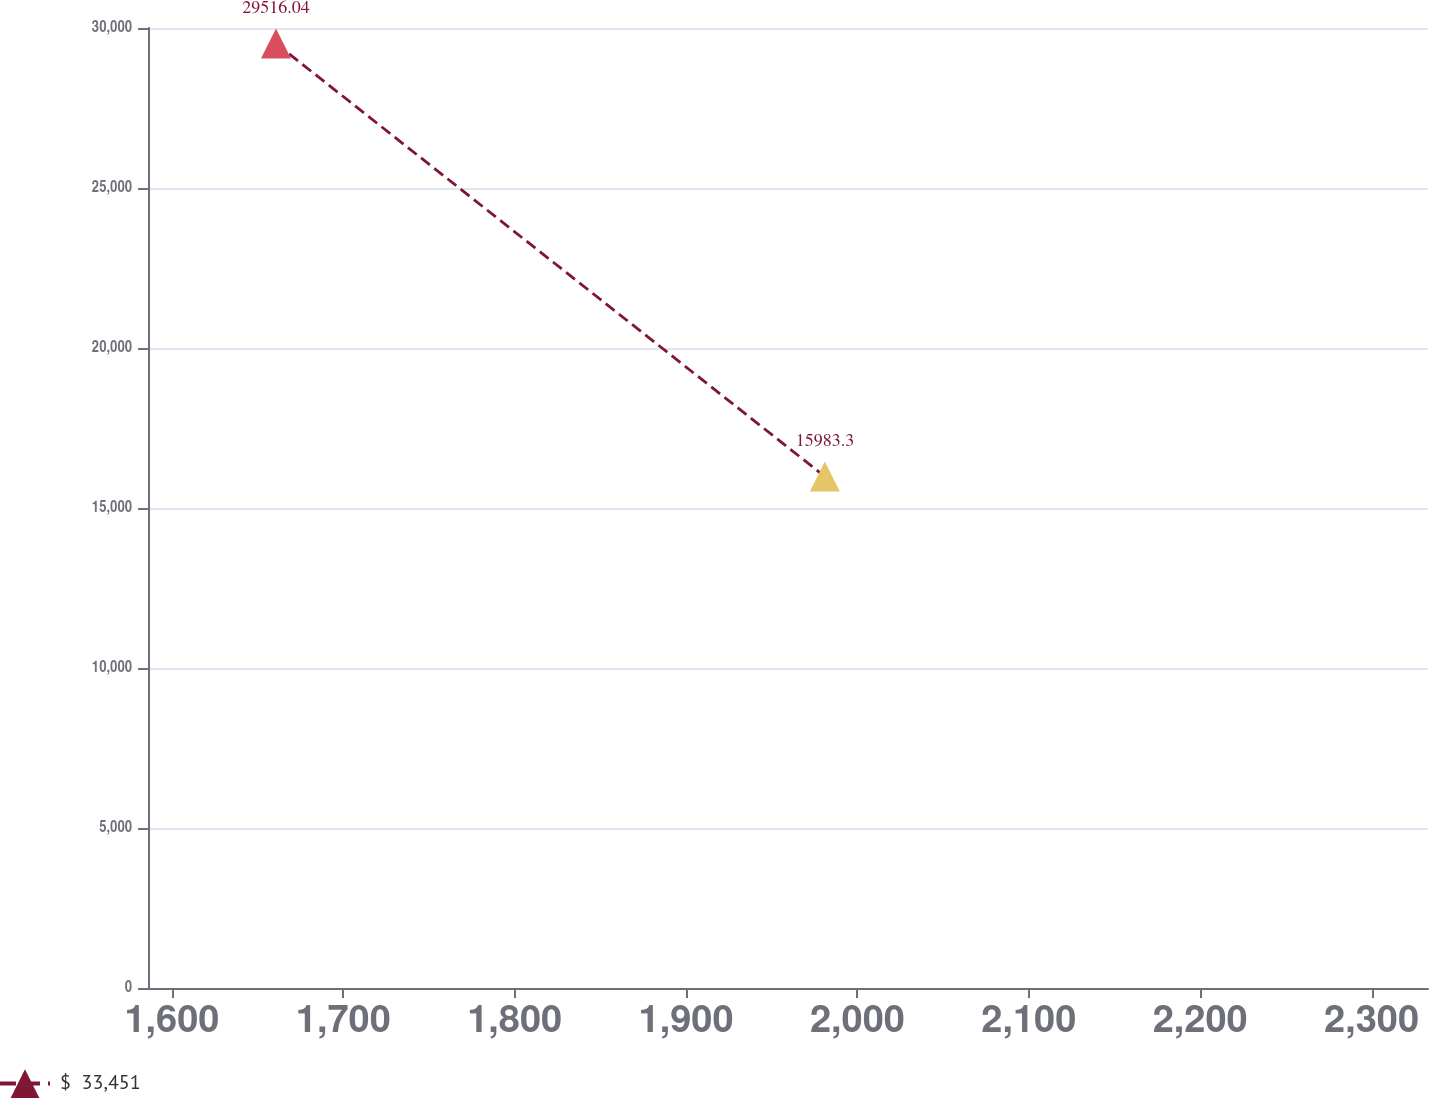<chart> <loc_0><loc_0><loc_500><loc_500><line_chart><ecel><fcel>$  33,451<nl><fcel>1660.73<fcel>29516<nl><fcel>1981.01<fcel>15983.3<nl><fcel>2334.36<fcel>7584.1<nl><fcel>2407.62<fcel>3454.35<nl></chart> 